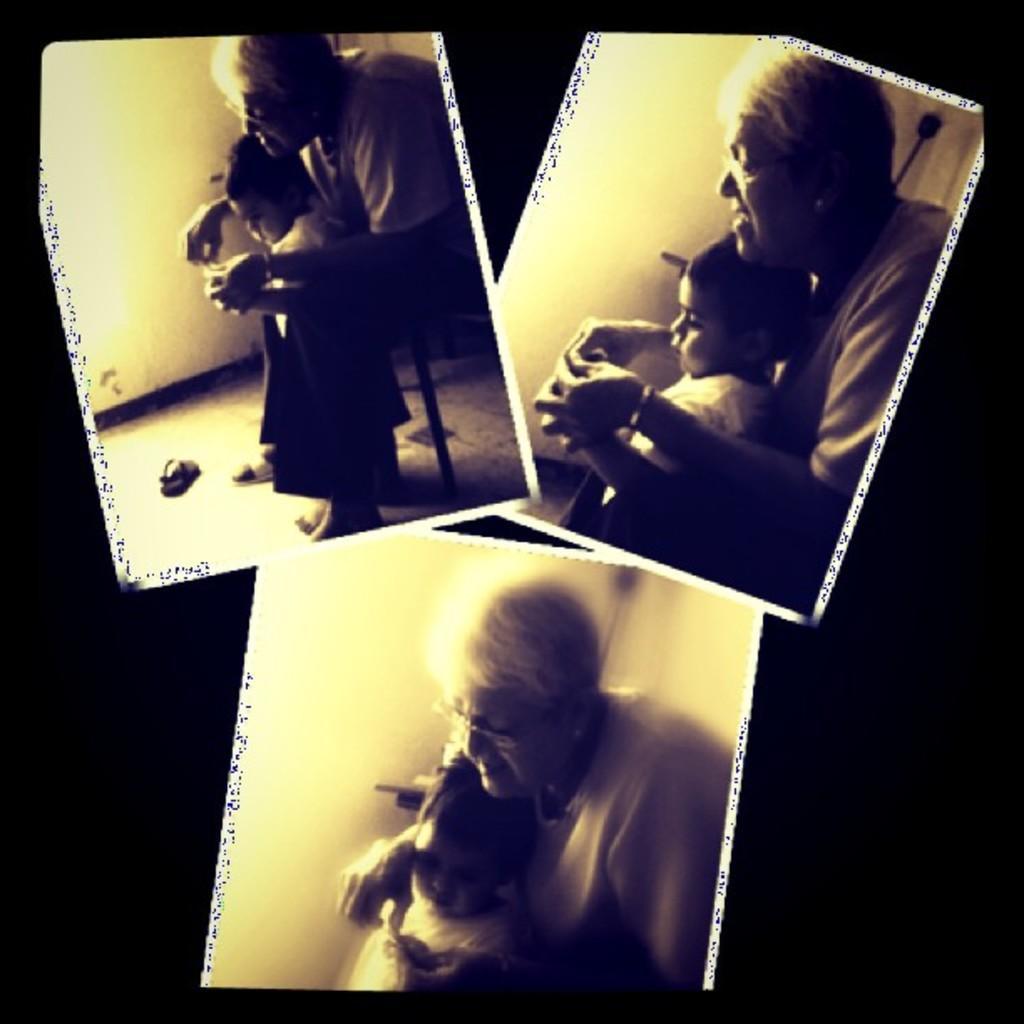Please provide a concise description of this image. In this picture we can see a collage image, in it one grandmother and one girl are playing images. 